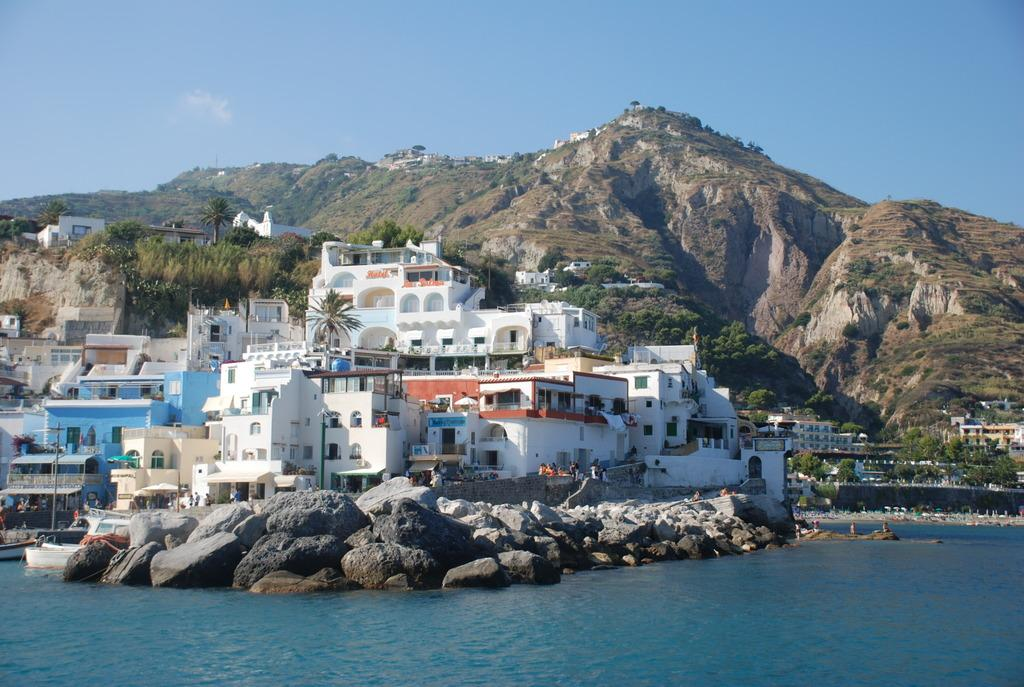What is in the water in the image? There are boats in the water in the image. What is located on the right side of the boats? There are rocks on the right side of the boats. What is behind the boats? There is a pole, buildings, trees, and hills behind the boats. What can be seen in the sky in the image? The sky is visible in the image. How many kittens are playing in the room behind the boats? There are no kittens or rooms present in the image; it features boats in the water with surrounding landscape. Can you tell me the color of the goose sitting on the pole behind the boats? There is no goose present on the pole or anywhere else in the image. 